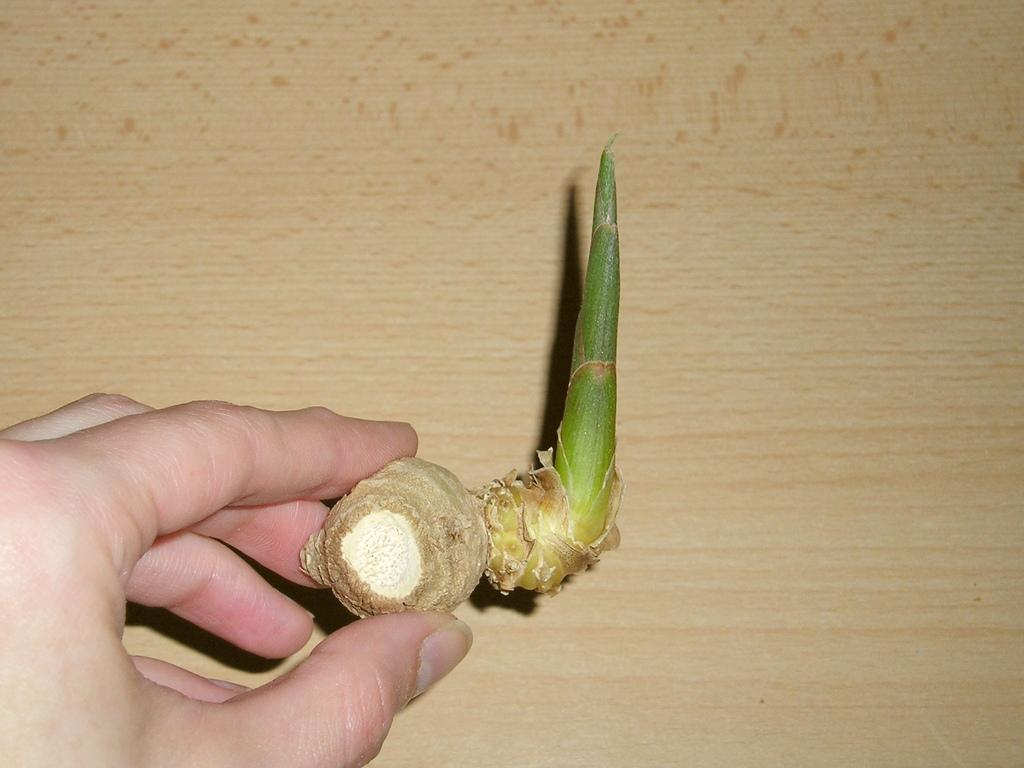What is the main subject of the image? The main subject of the image is a hand holding an object. What is the object being held by the hand? The object appears to be ginger. Can you describe anything in the background of the image? There is a wooden object in the background of the image. How many crackers are visible in the image? There are no people, let alone crackers, visible in the image. What type of spiders can be seen crawling on the wooden object in the background? There are no spiders present in the image, and the wooden object is not mentioned to have any spiders on it. 